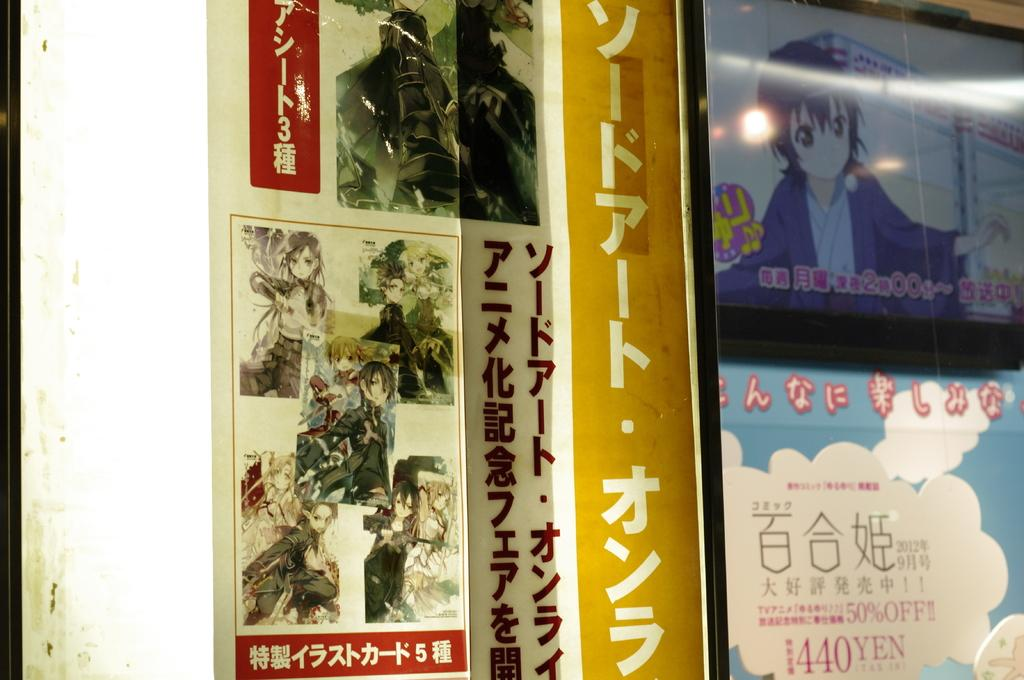<image>
Render a clear and concise summary of the photo. magazine posters that say 440yen on one of them 